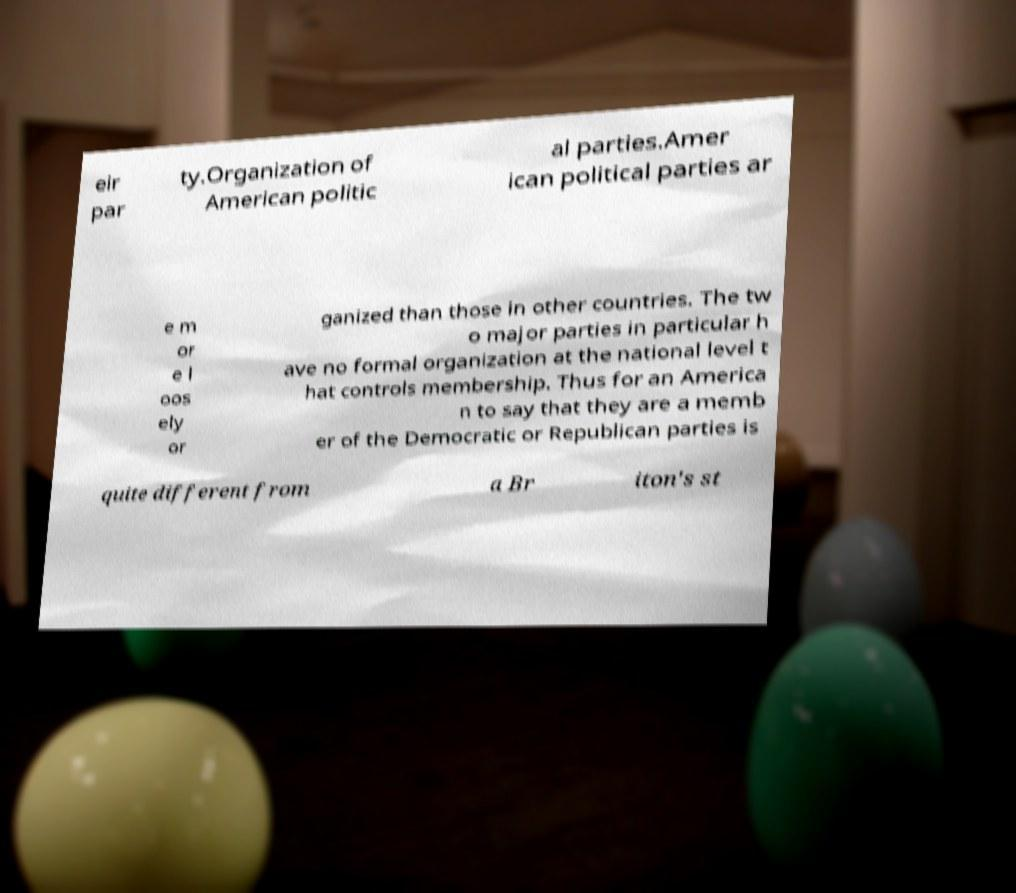Can you read and provide the text displayed in the image?This photo seems to have some interesting text. Can you extract and type it out for me? eir par ty.Organization of American politic al parties.Amer ican political parties ar e m or e l oos ely or ganized than those in other countries. The tw o major parties in particular h ave no formal organization at the national level t hat controls membership. Thus for an America n to say that they are a memb er of the Democratic or Republican parties is quite different from a Br iton's st 